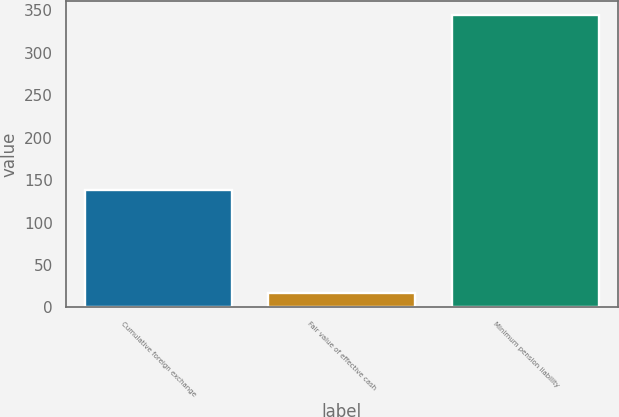Convert chart. <chart><loc_0><loc_0><loc_500><loc_500><bar_chart><fcel>Cumulative foreign exchange<fcel>Fair value of effective cash<fcel>Minimum pension liability<nl><fcel>138<fcel>17<fcel>344<nl></chart> 